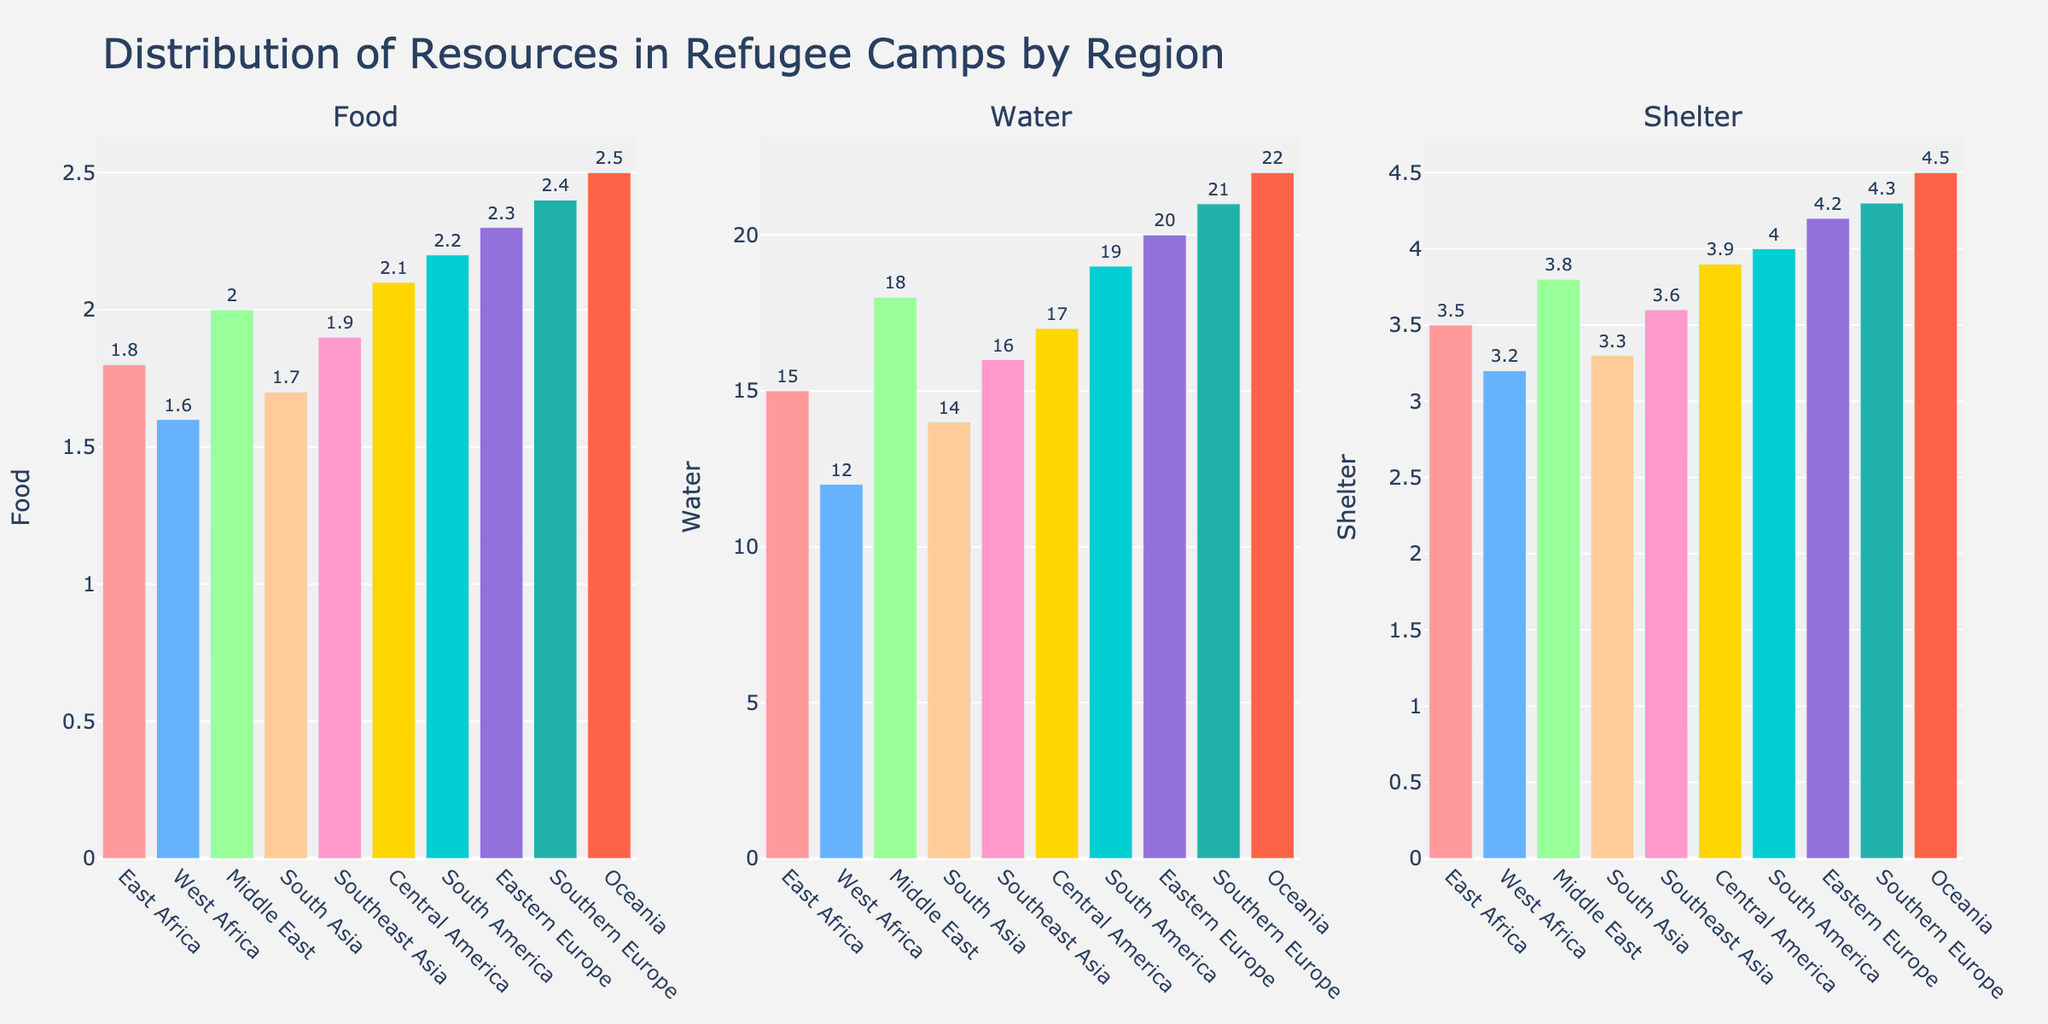Which region has the highest amount of food available per person per day? By comparing the height of the bars in the "Food" subplot, we see that Oceania has the tallest bar, indicating the highest amount of food available.
Answer: Oceania Which region has the lowest water supply per person per day? By looking at the "Water" subplot, the bar for West Africa is the shortest, indicating the lowest water supply.
Answer: West Africa How much more shelter space is available in Southern Europe compared to East Africa? Subtract the value for East Africa (3.5 sq m) from the value for Southern Europe (4.3 sq m): 4.3 - 3.5
Answer: 0.8 Which regions have a food supply greater than 2.0 kg/person/day? The bars for Central America, South America, Eastern Europe, Southern Europe, and Oceania in the "Food" subplot are higher than 2.0 kg/person/day.
Answer: Central America, South America, Eastern Europe, Southern Europe, Oceania What is the average amount of water available per person per day across all regions? Sum up the water values and divide by the number of regions: (15+12+18+14+16+17+19+20+21+22)/10 = 174/10
Answer: 17.4 Is the food supply in the Middle East greater than in Southeast Asia? Compare the heights of the bars in the "Food" subplot for Middle East (2.0) and Southeast Asia (1.9). The bar for Middle East is taller.
Answer: Yes What is the total shelter space available in Central America and South America? Sum the shelter values for Central America (3.9 sq m) and South America (4.0 sq m): 3.9 + 4.0
Answer: 7.9 Which region has the highest overall distribution of resources (food, water, and shelter)? The region with the highest values across all three subplots. Oceania has the highest values for both food and shelter, and the highest water value.
Answer: Oceania How does the water supply in South America compare to that in Southern Europe? Compare the bar heights in the "Water" subplot: South America has 19 L/person/day, and Southern Europe has 21 L/person/day. The bar for Southern Europe is taller.
Answer: Southern Europe has more 